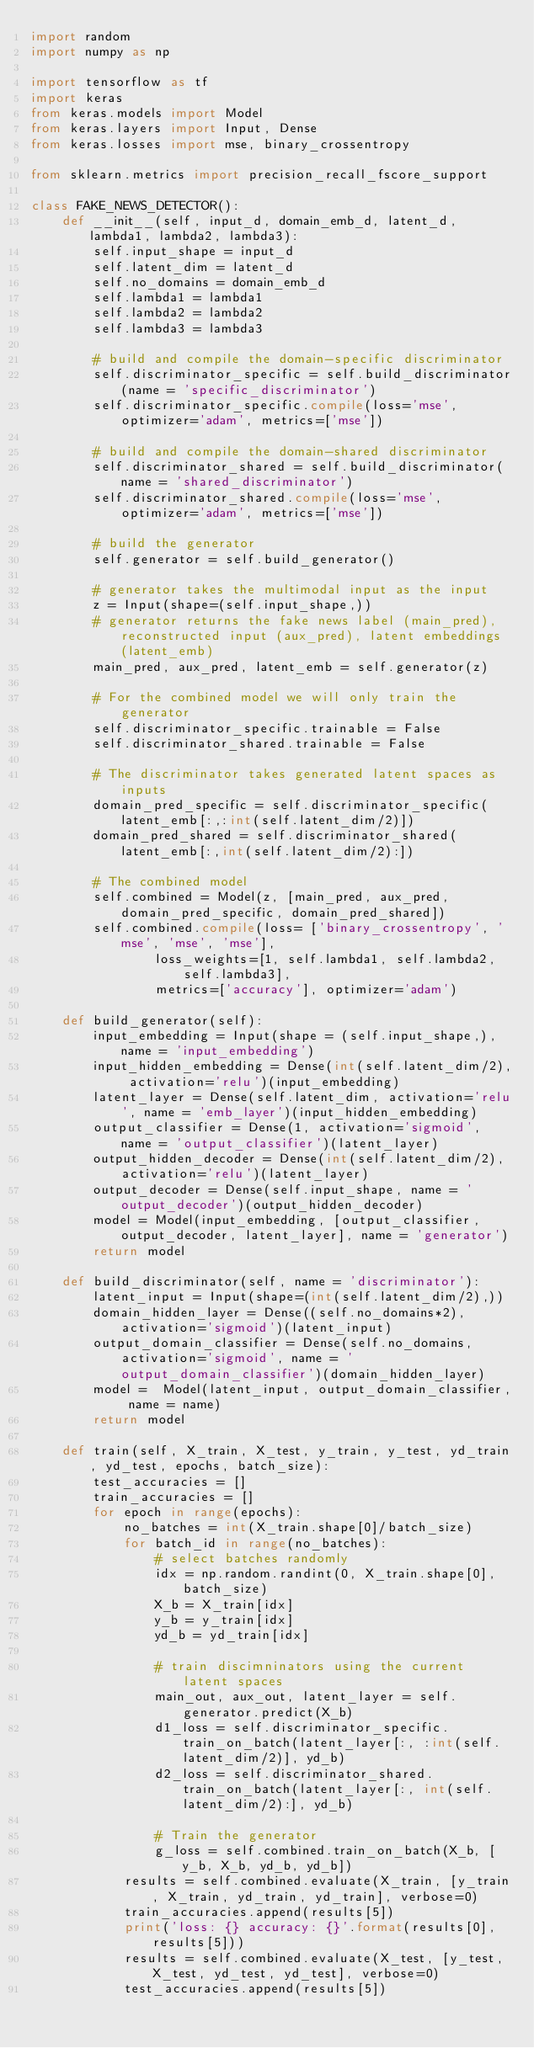Convert code to text. <code><loc_0><loc_0><loc_500><loc_500><_Python_>import random
import numpy as np

import tensorflow as tf
import keras
from keras.models import Model
from keras.layers import Input, Dense
from keras.losses import mse, binary_crossentropy

from sklearn.metrics import precision_recall_fscore_support

class FAKE_NEWS_DETECTOR():
    def __init__(self, input_d, domain_emb_d, latent_d, lambda1, lambda2, lambda3):
        self.input_shape = input_d
        self.latent_dim = latent_d
        self.no_domains = domain_emb_d
        self.lambda1 = lambda1
        self.lambda2 = lambda2
        self.lambda3 = lambda3

        # build and compile the domain-specific discriminator
        self.discriminator_specific = self.build_discriminator(name = 'specific_discriminator')
        self.discriminator_specific.compile(loss='mse', optimizer='adam', metrics=['mse'])

        # build and compile the domain-shared discriminator
        self.discriminator_shared = self.build_discriminator(name = 'shared_discriminator')
        self.discriminator_shared.compile(loss='mse', optimizer='adam', metrics=['mse'])

        # build the generator
        self.generator = self.build_generator()

        # generator takes the multimodal input as the input
        z = Input(shape=(self.input_shape,))
        # generator returns the fake news label (main_pred), reconstructed input (aux_pred), latent embeddings (latent_emb)
        main_pred, aux_pred, latent_emb = self.generator(z)

        # For the combined model we will only train the generator
        self.discriminator_specific.trainable = False
        self.discriminator_shared.trainable = False

        # The discriminator takes generated latent spaces as inputs
        domain_pred_specific = self.discriminator_specific(latent_emb[:,:int(self.latent_dim/2)])
        domain_pred_shared = self.discriminator_shared(latent_emb[:,int(self.latent_dim/2):])

        # The combined model
        self.combined = Model(z, [main_pred, aux_pred, domain_pred_specific, domain_pred_shared])
        self.combined.compile(loss= ['binary_crossentropy', 'mse', 'mse', 'mse'],
                loss_weights=[1, self.lambda1, self.lambda2, self.lambda3],
                metrics=['accuracy'], optimizer='adam')

    def build_generator(self):
        input_embedding = Input(shape = (self.input_shape,), name = 'input_embedding')
        input_hidden_embedding = Dense(int(self.latent_dim/2), activation='relu')(input_embedding)
        latent_layer = Dense(self.latent_dim, activation='relu', name = 'emb_layer')(input_hidden_embedding)
        output_classifier = Dense(1, activation='sigmoid', name = 'output_classifier')(latent_layer)
        output_hidden_decoder = Dense(int(self.latent_dim/2), activation='relu')(latent_layer)
        output_decoder = Dense(self.input_shape, name = 'output_decoder')(output_hidden_decoder)
        model = Model(input_embedding, [output_classifier, output_decoder, latent_layer], name = 'generator')
        return model

    def build_discriminator(self, name = 'discriminator'):
        latent_input = Input(shape=(int(self.latent_dim/2),))
        domain_hidden_layer = Dense((self.no_domains*2), activation='sigmoid')(latent_input)
        output_domain_classifier = Dense(self.no_domains, activation='sigmoid', name = 'output_domain_classifier')(domain_hidden_layer)
        model =  Model(latent_input, output_domain_classifier, name = name)
        return model

    def train(self, X_train, X_test, y_train, y_test, yd_train, yd_test, epochs, batch_size):
        test_accuracies = []
        train_accuracies = []
        for epoch in range(epochs):
            no_batches = int(X_train.shape[0]/batch_size)
            for batch_id in range(no_batches):
                # select batches randomly
                idx = np.random.randint(0, X_train.shape[0], batch_size)
                X_b = X_train[idx]
                y_b = y_train[idx]
                yd_b = yd_train[idx]

                # train discimninators using the current latent spaces
                main_out, aux_out, latent_layer = self.generator.predict(X_b)
                d1_loss = self.discriminator_specific.train_on_batch(latent_layer[:, :int(self.latent_dim/2)], yd_b)
                d2_loss = self.discriminator_shared.train_on_batch(latent_layer[:, int(self.latent_dim/2):], yd_b)

                # Train the generator
                g_loss = self.combined.train_on_batch(X_b, [y_b, X_b, yd_b, yd_b])
            results = self.combined.evaluate(X_train, [y_train, X_train, yd_train, yd_train], verbose=0)
            train_accuracies.append(results[5])
            print('loss: {} accuracy: {}'.format(results[0], results[5]))
            results = self.combined.evaluate(X_test, [y_test, X_test, yd_test, yd_test], verbose=0)
            test_accuracies.append(results[5])
</code> 